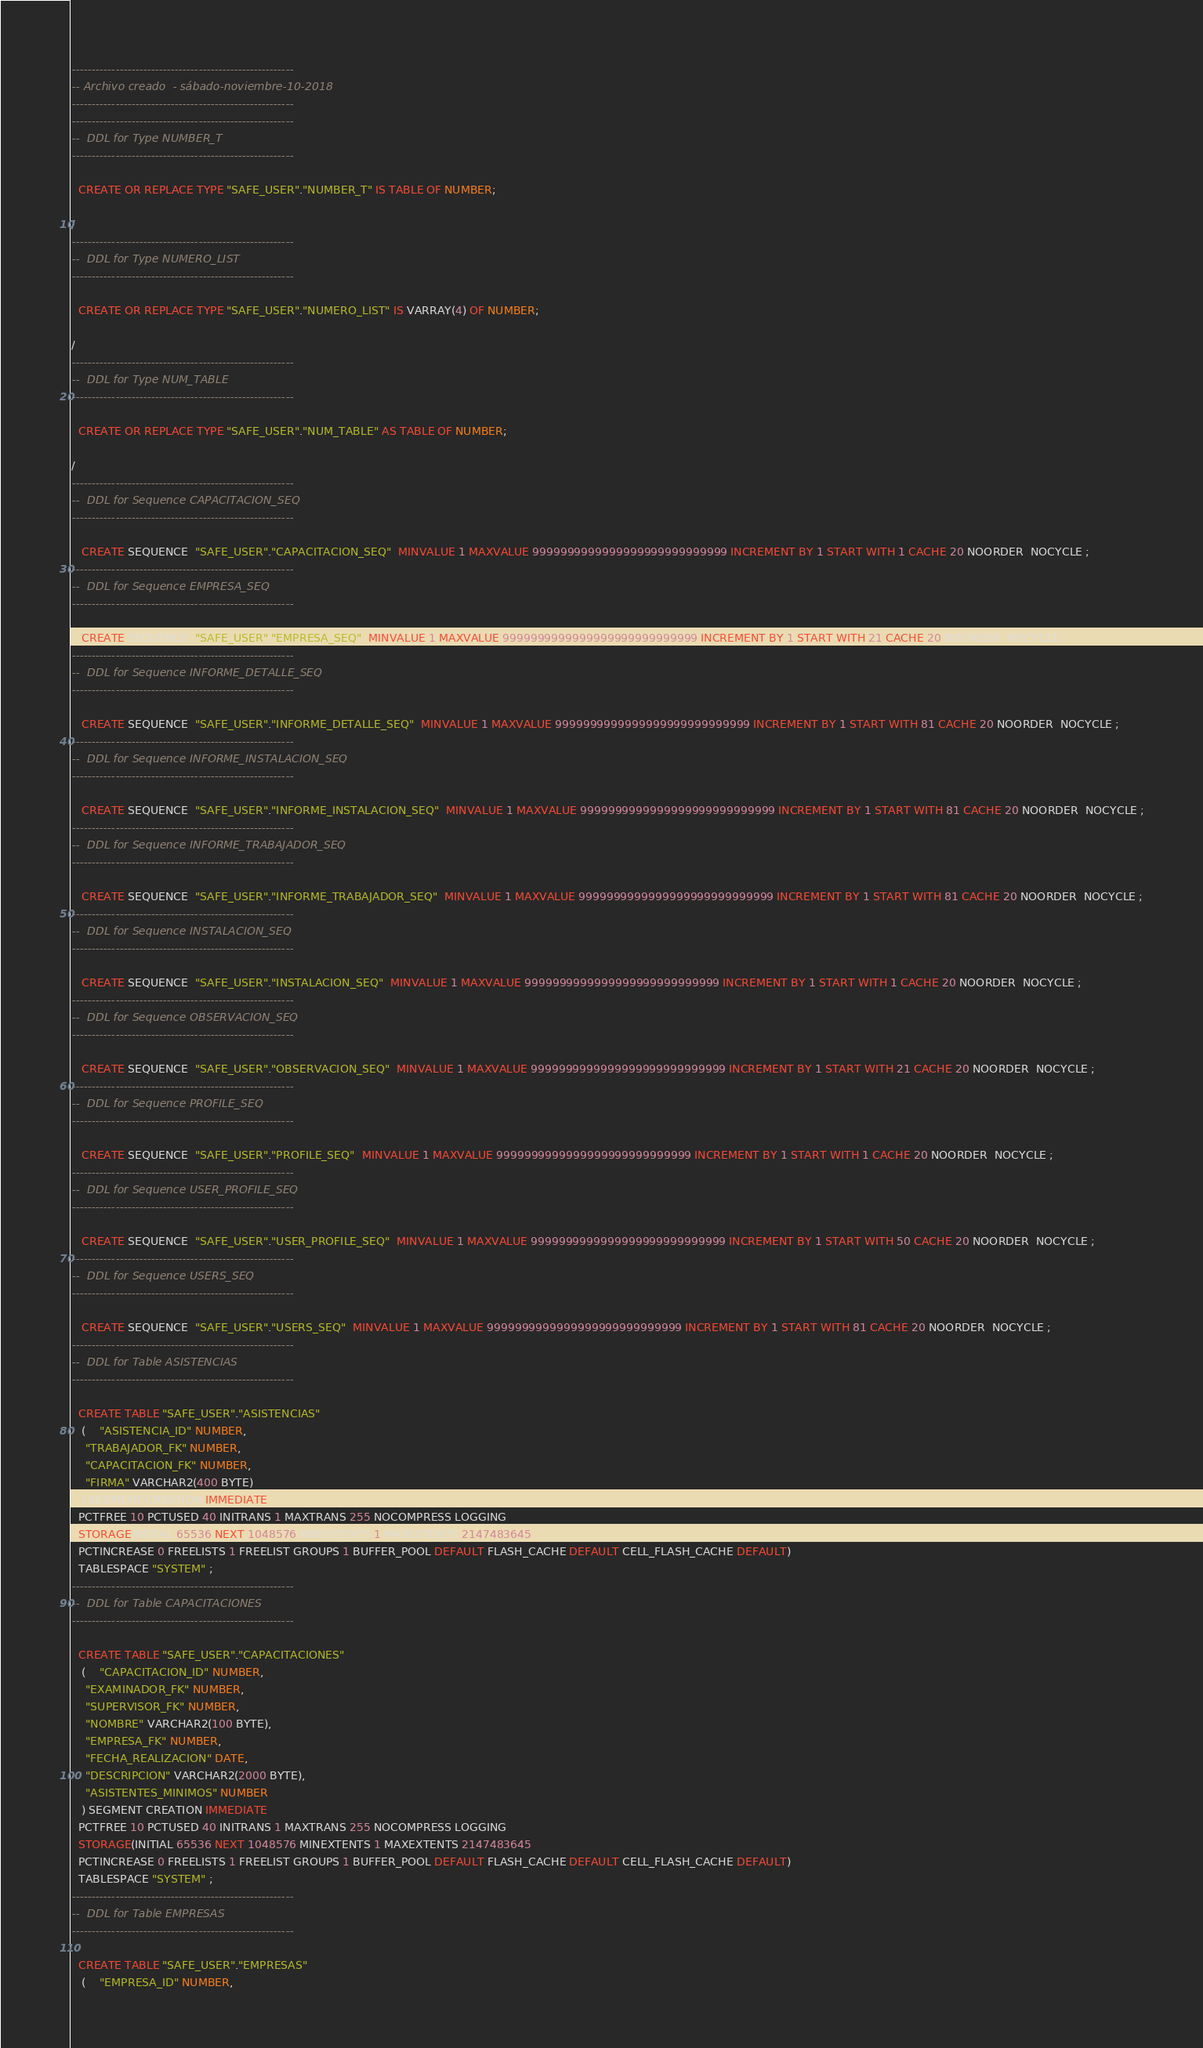<code> <loc_0><loc_0><loc_500><loc_500><_SQL_>--------------------------------------------------------
-- Archivo creado  - sábado-noviembre-10-2018   
--------------------------------------------------------
--------------------------------------------------------
--  DDL for Type NUMBER_T
--------------------------------------------------------

  CREATE OR REPLACE TYPE "SAFE_USER"."NUMBER_T" IS TABLE OF NUMBER;

/
--------------------------------------------------------
--  DDL for Type NUMERO_LIST
--------------------------------------------------------

  CREATE OR REPLACE TYPE "SAFE_USER"."NUMERO_LIST" IS VARRAY(4) OF NUMBER;

/
--------------------------------------------------------
--  DDL for Type NUM_TABLE
--------------------------------------------------------

  CREATE OR REPLACE TYPE "SAFE_USER"."NUM_TABLE" AS TABLE OF NUMBER;

/
--------------------------------------------------------
--  DDL for Sequence CAPACITACION_SEQ
--------------------------------------------------------

   CREATE SEQUENCE  "SAFE_USER"."CAPACITACION_SEQ"  MINVALUE 1 MAXVALUE 9999999999999999999999999999 INCREMENT BY 1 START WITH 1 CACHE 20 NOORDER  NOCYCLE ;
--------------------------------------------------------
--  DDL for Sequence EMPRESA_SEQ
--------------------------------------------------------

   CREATE SEQUENCE  "SAFE_USER"."EMPRESA_SEQ"  MINVALUE 1 MAXVALUE 9999999999999999999999999999 INCREMENT BY 1 START WITH 21 CACHE 20 NOORDER  NOCYCLE ;
--------------------------------------------------------
--  DDL for Sequence INFORME_DETALLE_SEQ
--------------------------------------------------------

   CREATE SEQUENCE  "SAFE_USER"."INFORME_DETALLE_SEQ"  MINVALUE 1 MAXVALUE 9999999999999999999999999999 INCREMENT BY 1 START WITH 81 CACHE 20 NOORDER  NOCYCLE ;
--------------------------------------------------------
--  DDL for Sequence INFORME_INSTALACION_SEQ
--------------------------------------------------------

   CREATE SEQUENCE  "SAFE_USER"."INFORME_INSTALACION_SEQ"  MINVALUE 1 MAXVALUE 9999999999999999999999999999 INCREMENT BY 1 START WITH 81 CACHE 20 NOORDER  NOCYCLE ;
--------------------------------------------------------
--  DDL for Sequence INFORME_TRABAJADOR_SEQ
--------------------------------------------------------

   CREATE SEQUENCE  "SAFE_USER"."INFORME_TRABAJADOR_SEQ"  MINVALUE 1 MAXVALUE 9999999999999999999999999999 INCREMENT BY 1 START WITH 81 CACHE 20 NOORDER  NOCYCLE ;
--------------------------------------------------------
--  DDL for Sequence INSTALACION_SEQ
--------------------------------------------------------

   CREATE SEQUENCE  "SAFE_USER"."INSTALACION_SEQ"  MINVALUE 1 MAXVALUE 9999999999999999999999999999 INCREMENT BY 1 START WITH 1 CACHE 20 NOORDER  NOCYCLE ;
--------------------------------------------------------
--  DDL for Sequence OBSERVACION_SEQ
--------------------------------------------------------

   CREATE SEQUENCE  "SAFE_USER"."OBSERVACION_SEQ"  MINVALUE 1 MAXVALUE 9999999999999999999999999999 INCREMENT BY 1 START WITH 21 CACHE 20 NOORDER  NOCYCLE ;
--------------------------------------------------------
--  DDL for Sequence PROFILE_SEQ
--------------------------------------------------------

   CREATE SEQUENCE  "SAFE_USER"."PROFILE_SEQ"  MINVALUE 1 MAXVALUE 9999999999999999999999999999 INCREMENT BY 1 START WITH 1 CACHE 20 NOORDER  NOCYCLE ;
--------------------------------------------------------
--  DDL for Sequence USER_PROFILE_SEQ
--------------------------------------------------------

   CREATE SEQUENCE  "SAFE_USER"."USER_PROFILE_SEQ"  MINVALUE 1 MAXVALUE 9999999999999999999999999999 INCREMENT BY 1 START WITH 50 CACHE 20 NOORDER  NOCYCLE ;
--------------------------------------------------------
--  DDL for Sequence USERS_SEQ
--------------------------------------------------------

   CREATE SEQUENCE  "SAFE_USER"."USERS_SEQ"  MINVALUE 1 MAXVALUE 9999999999999999999999999999 INCREMENT BY 1 START WITH 81 CACHE 20 NOORDER  NOCYCLE ;
--------------------------------------------------------
--  DDL for Table ASISTENCIAS
--------------------------------------------------------

  CREATE TABLE "SAFE_USER"."ASISTENCIAS" 
   (	"ASISTENCIA_ID" NUMBER, 
	"TRABAJADOR_FK" NUMBER, 
	"CAPACITACION_FK" NUMBER, 
	"FIRMA" VARCHAR2(400 BYTE)
   ) SEGMENT CREATION IMMEDIATE 
  PCTFREE 10 PCTUSED 40 INITRANS 1 MAXTRANS 255 NOCOMPRESS LOGGING
  STORAGE(INITIAL 65536 NEXT 1048576 MINEXTENTS 1 MAXEXTENTS 2147483645
  PCTINCREASE 0 FREELISTS 1 FREELIST GROUPS 1 BUFFER_POOL DEFAULT FLASH_CACHE DEFAULT CELL_FLASH_CACHE DEFAULT)
  TABLESPACE "SYSTEM" ;
--------------------------------------------------------
--  DDL for Table CAPACITACIONES
--------------------------------------------------------

  CREATE TABLE "SAFE_USER"."CAPACITACIONES" 
   (	"CAPACITACION_ID" NUMBER, 
	"EXAMINADOR_FK" NUMBER, 
	"SUPERVISOR_FK" NUMBER, 
	"NOMBRE" VARCHAR2(100 BYTE), 
	"EMPRESA_FK" NUMBER, 
	"FECHA_REALIZACION" DATE, 
	"DESCRIPCION" VARCHAR2(2000 BYTE), 
	"ASISTENTES_MINIMOS" NUMBER
   ) SEGMENT CREATION IMMEDIATE 
  PCTFREE 10 PCTUSED 40 INITRANS 1 MAXTRANS 255 NOCOMPRESS LOGGING
  STORAGE(INITIAL 65536 NEXT 1048576 MINEXTENTS 1 MAXEXTENTS 2147483645
  PCTINCREASE 0 FREELISTS 1 FREELIST GROUPS 1 BUFFER_POOL DEFAULT FLASH_CACHE DEFAULT CELL_FLASH_CACHE DEFAULT)
  TABLESPACE "SYSTEM" ;
--------------------------------------------------------
--  DDL for Table EMPRESAS
--------------------------------------------------------

  CREATE TABLE "SAFE_USER"."EMPRESAS" 
   (	"EMPRESA_ID" NUMBER, </code> 